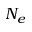Convert formula to latex. <formula><loc_0><loc_0><loc_500><loc_500>N _ { e }</formula> 